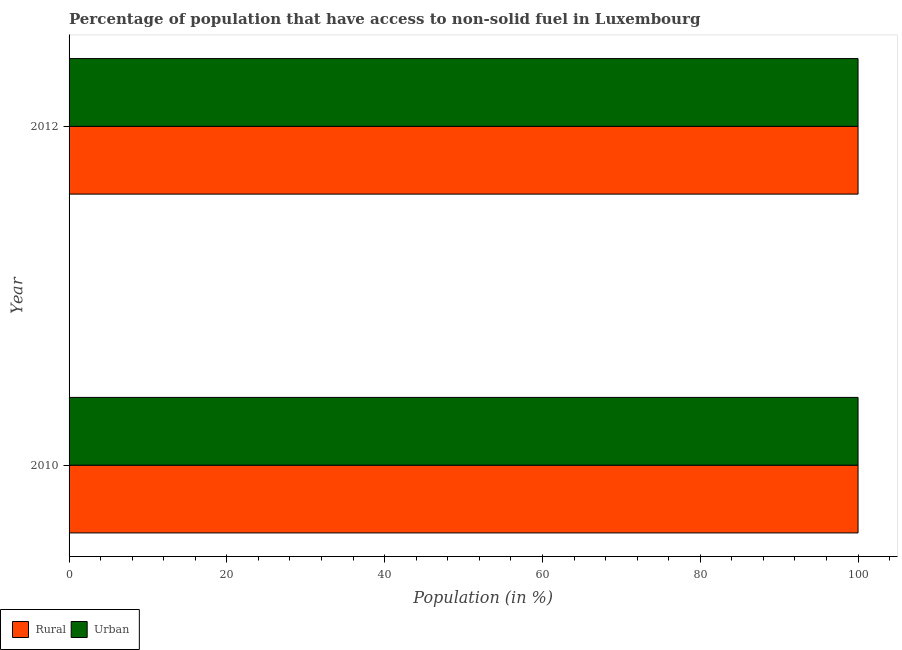How many groups of bars are there?
Offer a terse response. 2. Are the number of bars per tick equal to the number of legend labels?
Offer a terse response. Yes. Are the number of bars on each tick of the Y-axis equal?
Your answer should be very brief. Yes. How many bars are there on the 1st tick from the top?
Your answer should be compact. 2. How many bars are there on the 1st tick from the bottom?
Your response must be concise. 2. What is the urban population in 2010?
Offer a terse response. 100. Across all years, what is the maximum urban population?
Ensure brevity in your answer.  100. Across all years, what is the minimum urban population?
Ensure brevity in your answer.  100. In which year was the rural population maximum?
Ensure brevity in your answer.  2010. In which year was the rural population minimum?
Offer a very short reply. 2010. What is the total rural population in the graph?
Your answer should be very brief. 200. What is the difference between the urban population in 2010 and the rural population in 2012?
Your answer should be compact. 0. In the year 2010, what is the difference between the rural population and urban population?
Provide a short and direct response. 0. What is the ratio of the rural population in 2010 to that in 2012?
Provide a short and direct response. 1. Is the urban population in 2010 less than that in 2012?
Keep it short and to the point. No. In how many years, is the rural population greater than the average rural population taken over all years?
Ensure brevity in your answer.  0. What does the 1st bar from the top in 2012 represents?
Provide a succinct answer. Urban. What does the 2nd bar from the bottom in 2012 represents?
Provide a succinct answer. Urban. Are all the bars in the graph horizontal?
Ensure brevity in your answer.  Yes. What is the difference between two consecutive major ticks on the X-axis?
Offer a very short reply. 20. Are the values on the major ticks of X-axis written in scientific E-notation?
Your answer should be very brief. No. Does the graph contain grids?
Ensure brevity in your answer.  No. How many legend labels are there?
Keep it short and to the point. 2. What is the title of the graph?
Give a very brief answer. Percentage of population that have access to non-solid fuel in Luxembourg. Does "Number of departures" appear as one of the legend labels in the graph?
Offer a very short reply. No. What is the label or title of the X-axis?
Make the answer very short. Population (in %). What is the label or title of the Y-axis?
Your response must be concise. Year. What is the Population (in %) of Urban in 2010?
Provide a short and direct response. 100. What is the Population (in %) in Urban in 2012?
Provide a succinct answer. 100. Across all years, what is the maximum Population (in %) in Rural?
Ensure brevity in your answer.  100. Across all years, what is the minimum Population (in %) of Rural?
Offer a very short reply. 100. What is the total Population (in %) in Rural in the graph?
Offer a terse response. 200. What is the difference between the Population (in %) in Urban in 2010 and that in 2012?
Provide a short and direct response. 0. What is the average Population (in %) of Rural per year?
Offer a very short reply. 100. In the year 2010, what is the difference between the Population (in %) in Rural and Population (in %) in Urban?
Your answer should be compact. 0. In the year 2012, what is the difference between the Population (in %) of Rural and Population (in %) of Urban?
Offer a very short reply. 0. What is the ratio of the Population (in %) of Rural in 2010 to that in 2012?
Offer a very short reply. 1. What is the ratio of the Population (in %) in Urban in 2010 to that in 2012?
Offer a very short reply. 1. What is the difference between the highest and the second highest Population (in %) of Rural?
Give a very brief answer. 0. What is the difference between the highest and the second highest Population (in %) of Urban?
Offer a terse response. 0. What is the difference between the highest and the lowest Population (in %) of Rural?
Give a very brief answer. 0. What is the difference between the highest and the lowest Population (in %) in Urban?
Ensure brevity in your answer.  0. 